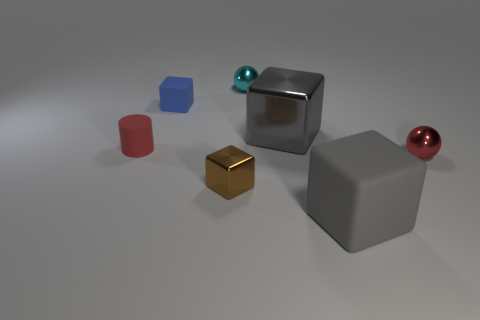Add 1 large gray metal blocks. How many objects exist? 8 Subtract all cyan balls. How many balls are left? 1 Subtract all gray metallic cubes. How many cubes are left? 3 Subtract 0 green cylinders. How many objects are left? 7 Subtract all cylinders. How many objects are left? 6 Subtract 1 spheres. How many spheres are left? 1 Subtract all cyan cylinders. Subtract all green blocks. How many cylinders are left? 1 Subtract all green cylinders. How many green cubes are left? 0 Subtract all red rubber cylinders. Subtract all tiny brown matte objects. How many objects are left? 6 Add 3 red cylinders. How many red cylinders are left? 4 